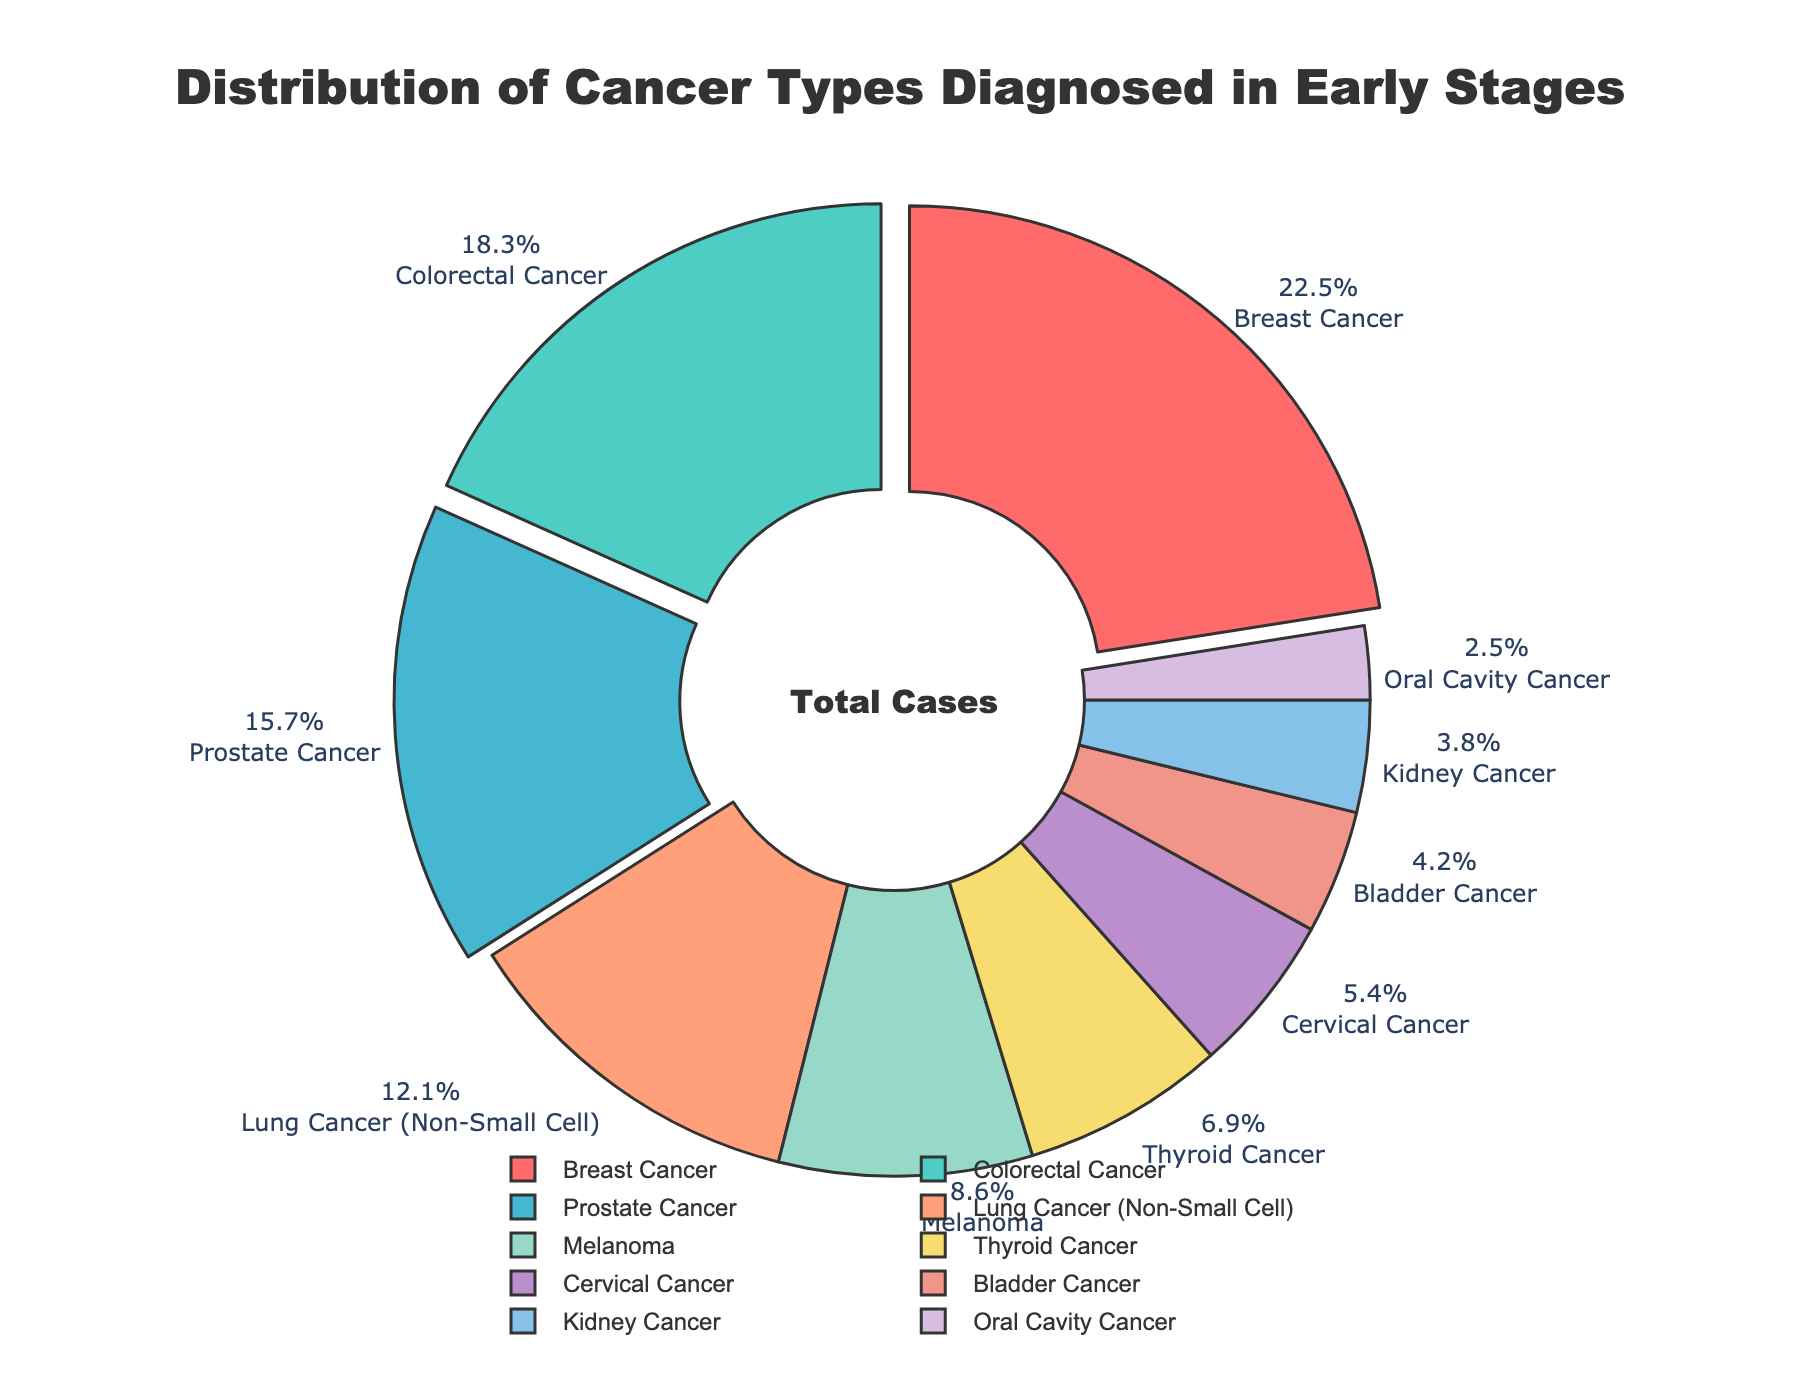What percentage of early-stage diagnosed cancers are Breast Cancer and Colorectal Cancer combined? To find the combined percentage, add the percentages for Breast Cancer (22.5%) and Colorectal Cancer (18.3%). Therefore, 22.5 + 18.3 = 40.8.
Answer: 40.8% Which cancer type has a larger early-stage diagnosis percentage, Prostate Cancer or Lung Cancer (Non-Small Cell)? Prostate Cancer has a percentage of 15.7%, while Lung Cancer (Non-Small Cell) has 12.1%. Thus, Prostate Cancer has a larger percentage.
Answer: Prostate Cancer What is the total percentage of the three smallest categories in terms of early-stage diagnosis? The three smallest categories are Oral Cavity Cancer (2.5%), Kidney Cancer (3.8%), and Bladder Cancer (4.2%). Adding these gives 2.5 + 3.8 + 4.2 = 10.5.
Answer: 10.5% Is there a cancer type with a percentage less than 5%? If yes, name them. Both Bladder Cancer (4.2%) and Oral Cavity Cancer (2.5%) have less than 5% of early-stage diagnoses.
Answer: Bladder Cancer, Oral Cavity Cancer What is the difference between the percentage of Breast Cancer and Thyroid Cancer diagnoses? Breast Cancer has 22.5%, and Thyroid Cancer has 6.9%. The difference is 22.5 - 6.9 = 15.6.
Answer: 15.6 What is the combined percentage of all cancer types that have an early-stage diagnosis percentage greater than 15%? The relevant cancer types are Breast Cancer (22.5%), Colorectal Cancer (18.3%), and Prostate Cancer (15.7%). Adding these gives 22.5 + 18.3 + 15.7 = 56.5.
Answer: 56.5% Which cancer type is represented with the color red in the pie chart? The description mentions that the first color in the custom color palette is red and it is assigned to Breast Cancer due to its first position in the list.
Answer: Breast Cancer How many cancer types have an early-stage diagnosis percentage greater than 10%? The cancer types greater than 10% are Breast Cancer (22.5%), Colorectal Cancer (18.3%), Prostate Cancer (15.7%), and Lung Cancer (Non-Small Cell) (12.1%). Counting these, there are 4 cancer types.
Answer: 4 Which cancer types are positioned between Breast Cancer and Thyroid Cancer in the cumulative sum order? By checking the cumulative sums, after Breast Cancer are Colorectal Cancer, Prostate Cancer, and Lung Cancer (Non-Small Cell) before reaching Thyroid Cancer.
Answer: Colorectal Cancer, Prostate Cancer, Lung Cancer (Non-Small Cell) 